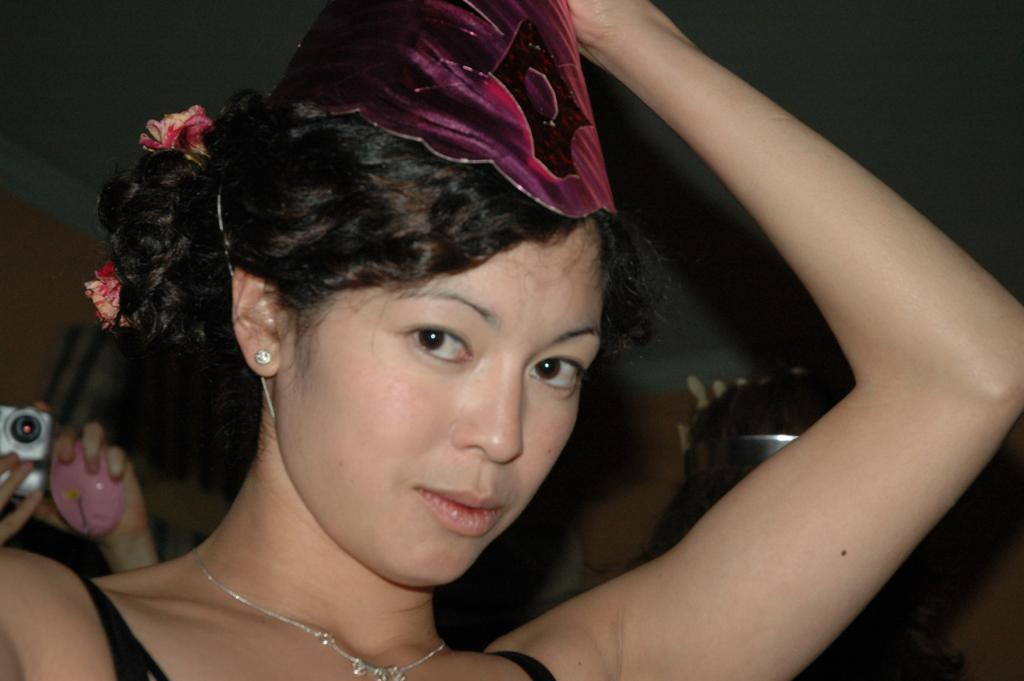Who is the main subject in the image? There is a woman in the image. Are there any other people visible in the image? Yes, there are people standing behind the woman. What are the people behind the woman holding? The people behind the woman are holding cameras. What type of drug is the boy using in the image? There is no boy or drug present in the image. 